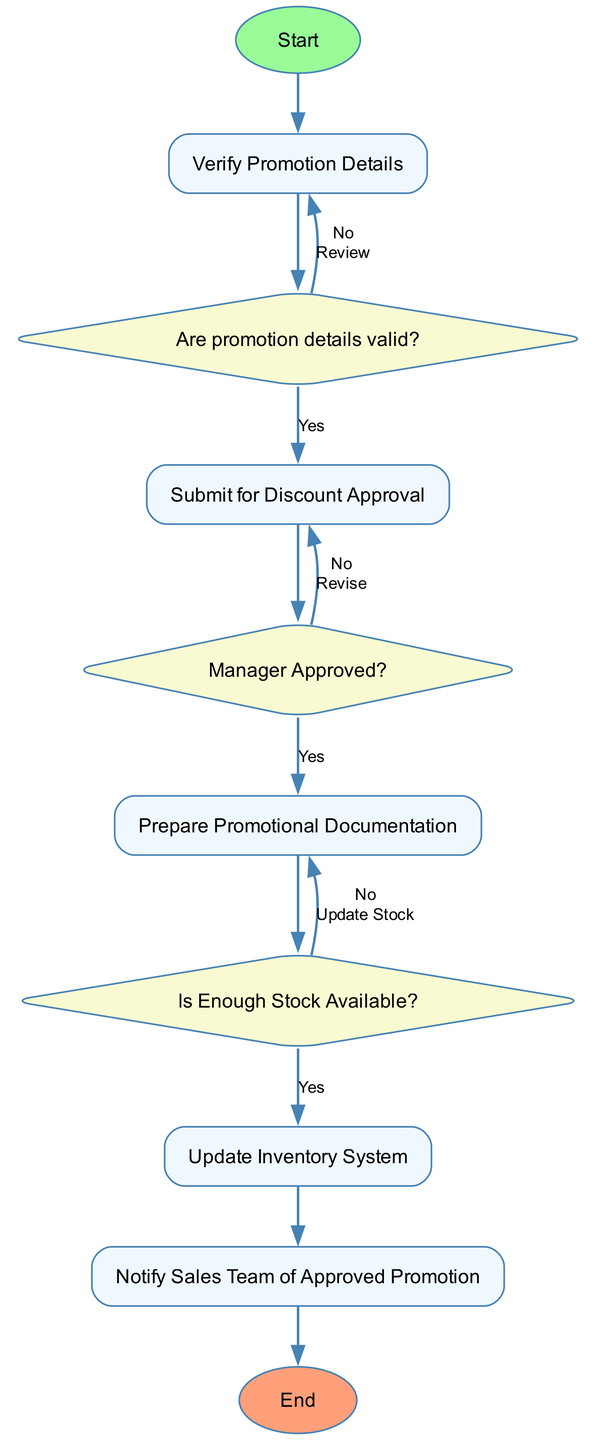What is the first step in the diagram? The diagram starts with the "Start" node, which indicates the initiation of the Promotion and Discount Approval Process. This is the first action taken before any verification or assessments are made regarding the promotion.
Answer: Start How many decision nodes are present in the diagram? The diagram contains three decision nodes: one for verifying promotion details, one for the manager approval, and one for checking stock availability. These nodes represent points where yes/no questions are asked that impact the flow of the process.
Answer: 3 What happens if the promotion details are invalid? If the promotion details are invalid, the flow goes to "Notify Sales Team to Review Promotion Details". This indicates that the sales team will be informed to re-evaluate or correct the promotion before it can proceed further.
Answer: Notify Sales Team to Review Promotion Details What is the output of the diagram if the stock is insufficient? If there is not enough stock available, the flow leads to "Notify Inventory Team for Stock Update", indicating that the inventory team will need to be notified to update stock levels before proceeding with the promotion.
Answer: Notify Inventory Team for Stock Update What action follows after document preparation? After "Prepare Promotional Documentation," the next action is to check if enough stock is available, indicated by the "Is Enough Stock Available?" decision node. The process is sequential, where documentation is prepared first before stock verification.
Answer: Is Enough Stock Available? What is the final action before the process ends? The final action before the process ends is "Notify Sales Team of Approved Promotion." This occurs after all approvals and verifications are complete, ensuring that the sales team is informed about the new promotion that has been cleared for execution.
Answer: Notify Sales Team of Approved Promotion What does the 'yes' outcome of the stock verification lead to? The 'yes' outcome of the stock verification leads to "Add Promotional Terms to Inventory Listings", indicating that once stock is confirmed to be sufficient, the promotional terms are included in the listings for customers to view.
Answer: Add Promotional Terms to Inventory Listings What occurs when the manager does not approve the discount? When the manager does not approve the discount, the process redirects back to "Notify Sales Team for Revision," which means the sales team will need to revise the proposed promotion before it can be approved.
Answer: Notify Sales Team for Revision 